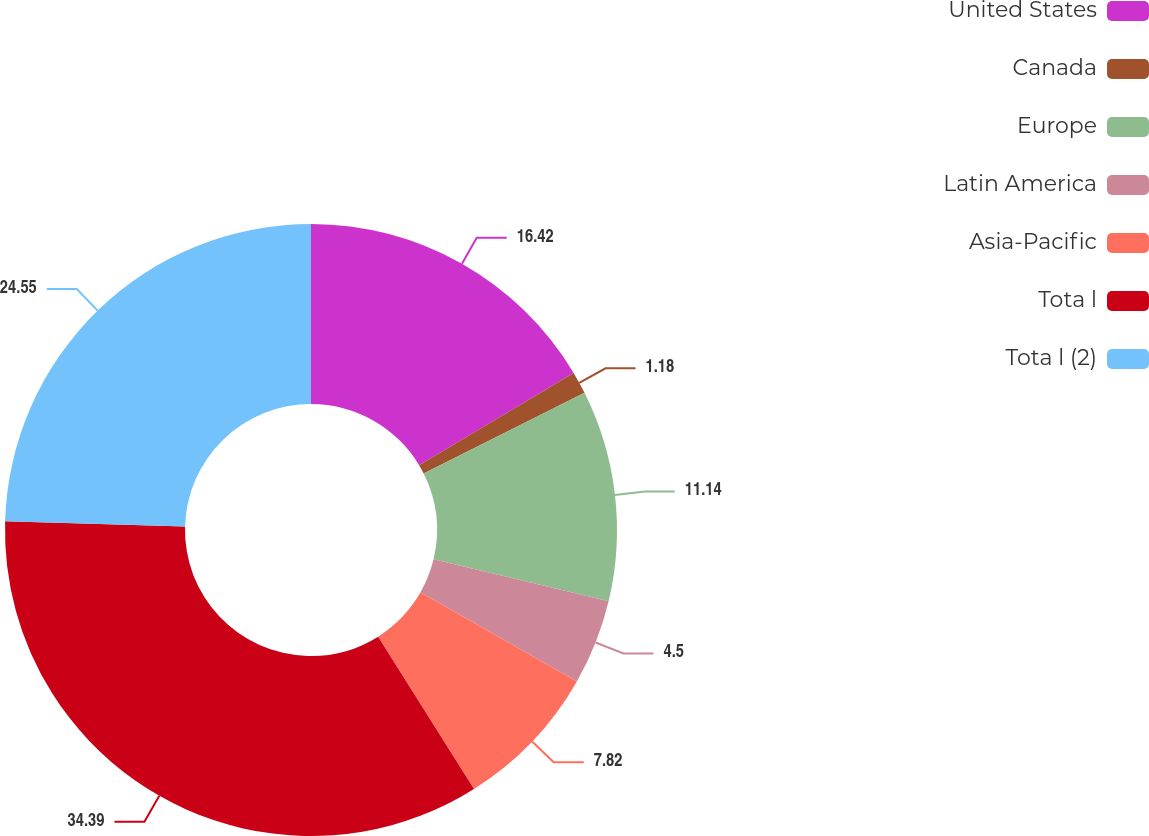Convert chart. <chart><loc_0><loc_0><loc_500><loc_500><pie_chart><fcel>United States<fcel>Canada<fcel>Europe<fcel>Latin America<fcel>Asia-Pacific<fcel>Tota l<fcel>Tota l (2)<nl><fcel>16.42%<fcel>1.18%<fcel>11.14%<fcel>4.5%<fcel>7.82%<fcel>34.39%<fcel>24.55%<nl></chart> 